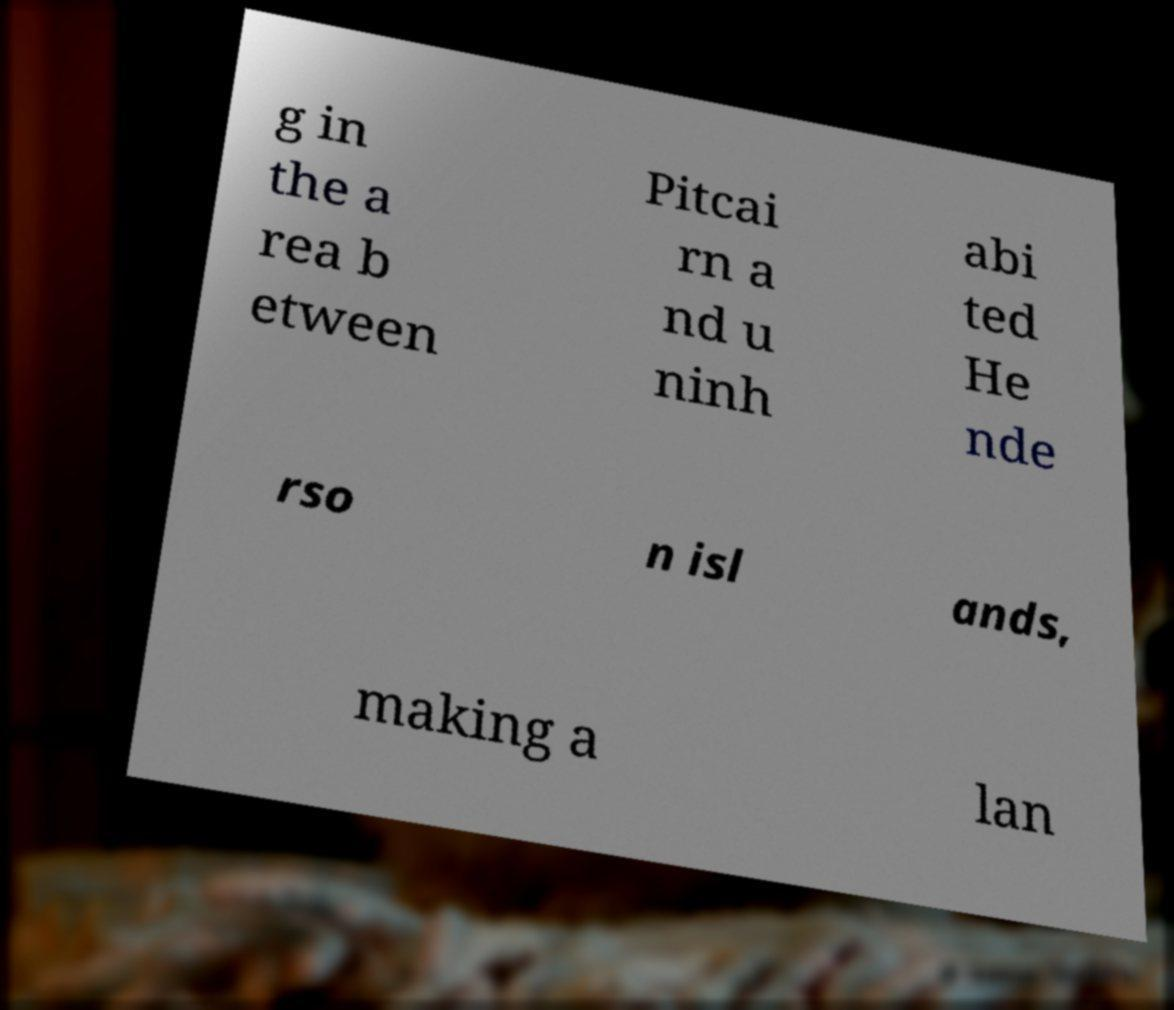Could you extract and type out the text from this image? g in the a rea b etween Pitcai rn a nd u ninh abi ted He nde rso n isl ands, making a lan 